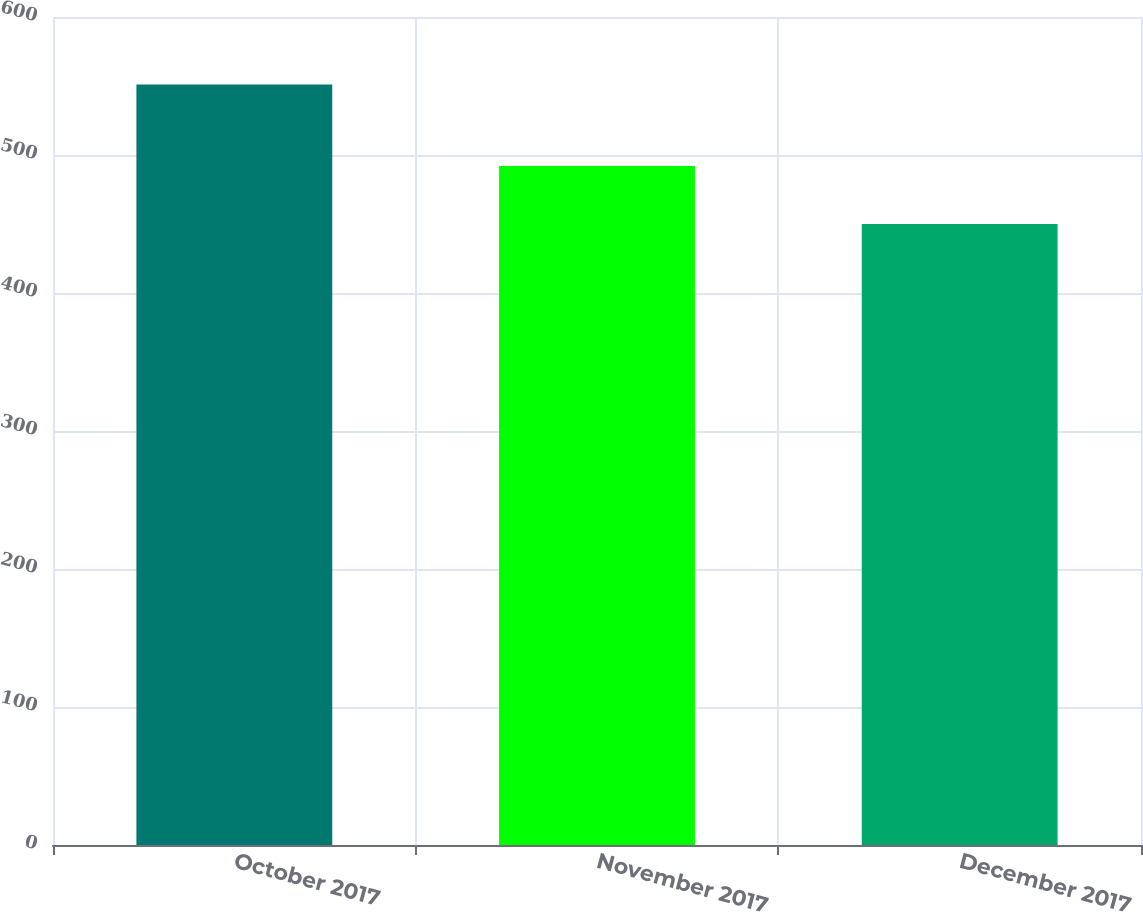Convert chart to OTSL. <chart><loc_0><loc_0><loc_500><loc_500><bar_chart><fcel>October 2017<fcel>November 2017<fcel>December 2017<nl><fcel>551<fcel>492<fcel>450<nl></chart> 